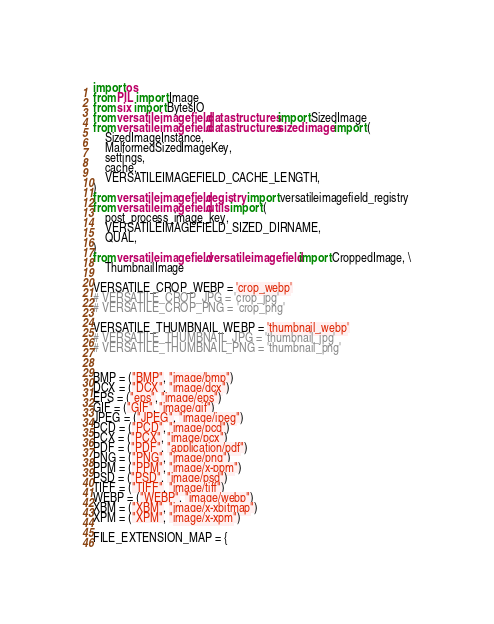Convert code to text. <code><loc_0><loc_0><loc_500><loc_500><_Python_>import os
from PIL import Image
from six import BytesIO
from versatileimagefield.datastructures import SizedImage
from versatileimagefield.datastructures.sizedimage import (
    SizedImageInstance,
    MalformedSizedImageKey,
    settings,
    cache,
    VERSATILEIMAGEFIELD_CACHE_LENGTH,
)
from versatileimagefield.registry import versatileimagefield_registry
from versatileimagefield.utils import (
    post_process_image_key,
    VERSATILEIMAGEFIELD_SIZED_DIRNAME,
    QUAL,
)
from versatileimagefield.versatileimagefield import CroppedImage, \
    ThumbnailImage

VERSATILE_CROP_WEBP = 'crop_webp'
# VERSATILE_CROP_JPG = 'crop_jpg'
# VERSATILE_CROP_PNG = 'crop_png'

VERSATILE_THUMBNAIL_WEBP = 'thumbnail_webp'
# VERSATILE_THUMBNAIL_JPG = 'thumbnail_jpg'
# VERSATILE_THUMBNAIL_PNG = 'thumbnail_png'


BMP = ("BMP", "image/bmp")
DCX = ("DCX", "image/dcx")
EPS = ("eps", "image/eps")
GIF = ("GIF", "image/gif")
JPEG = ("JPEG", "image/jpeg")
PCD = ("PCD", "image/pcd")
PCX = ("PCX", "image/pcx")
PDF = ("PDF", "application/pdf")
PNG = ("PNG", "image/png")
PPM = ("PPM", "image/x-ppm")
PSD = ("PSD", "image/psd")
TIFF = ("TIFF", "image/tiff")
WEBP = ("WEBP", "image/webp")
XBM = ("XBM", "image/x-xbitmap")
XPM = ("XPM", "image/x-xpm")

FILE_EXTENSION_MAP = {</code> 